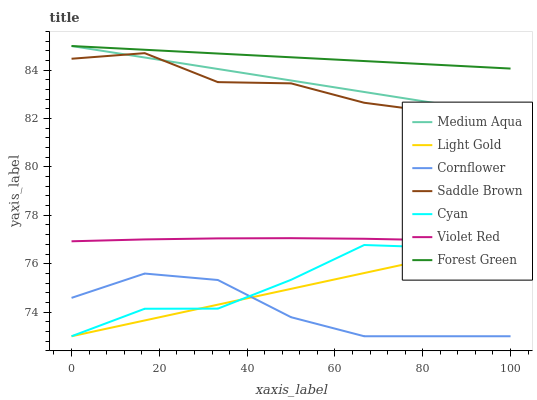Does Cornflower have the minimum area under the curve?
Answer yes or no. Yes. Does Forest Green have the maximum area under the curve?
Answer yes or no. Yes. Does Violet Red have the minimum area under the curve?
Answer yes or no. No. Does Violet Red have the maximum area under the curve?
Answer yes or no. No. Is Forest Green the smoothest?
Answer yes or no. Yes. Is Cyan the roughest?
Answer yes or no. Yes. Is Violet Red the smoothest?
Answer yes or no. No. Is Violet Red the roughest?
Answer yes or no. No. Does Cornflower have the lowest value?
Answer yes or no. Yes. Does Violet Red have the lowest value?
Answer yes or no. No. Does Medium Aqua have the highest value?
Answer yes or no. Yes. Does Violet Red have the highest value?
Answer yes or no. No. Is Light Gold less than Saddle Brown?
Answer yes or no. Yes. Is Forest Green greater than Cornflower?
Answer yes or no. Yes. Does Cornflower intersect Cyan?
Answer yes or no. Yes. Is Cornflower less than Cyan?
Answer yes or no. No. Is Cornflower greater than Cyan?
Answer yes or no. No. Does Light Gold intersect Saddle Brown?
Answer yes or no. No. 